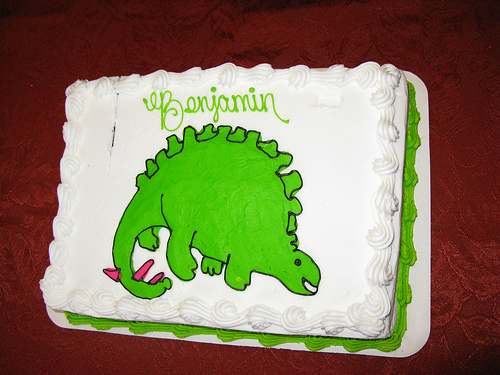<image>
Is there a dinosaur on the cake? Yes. Looking at the image, I can see the dinosaur is positioned on top of the cake, with the cake providing support. 